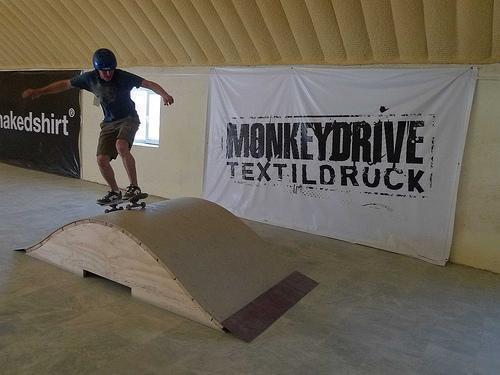How many people are in the picture?
Give a very brief answer. 1. How many shoes is the man wearing?
Give a very brief answer. 2. 